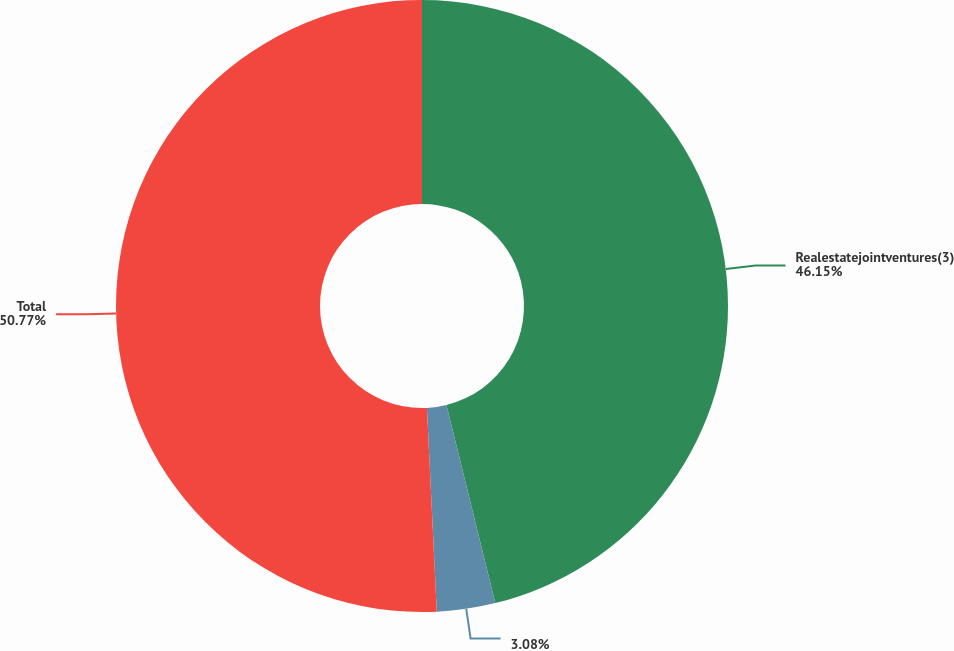<chart> <loc_0><loc_0><loc_500><loc_500><pie_chart><fcel>Realestatejointventures(3)<fcel>Unnamed: 1<fcel>Total<nl><fcel>46.15%<fcel>3.08%<fcel>50.77%<nl></chart> 